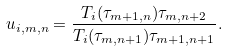<formula> <loc_0><loc_0><loc_500><loc_500>u _ { i , m , n } = \frac { T _ { i } ( \tau _ { m + 1 , n } ) \tau _ { m , n + 2 } } { T _ { i } ( \tau _ { m , n + 1 } ) \tau _ { m + 1 , n + 1 } } .</formula> 